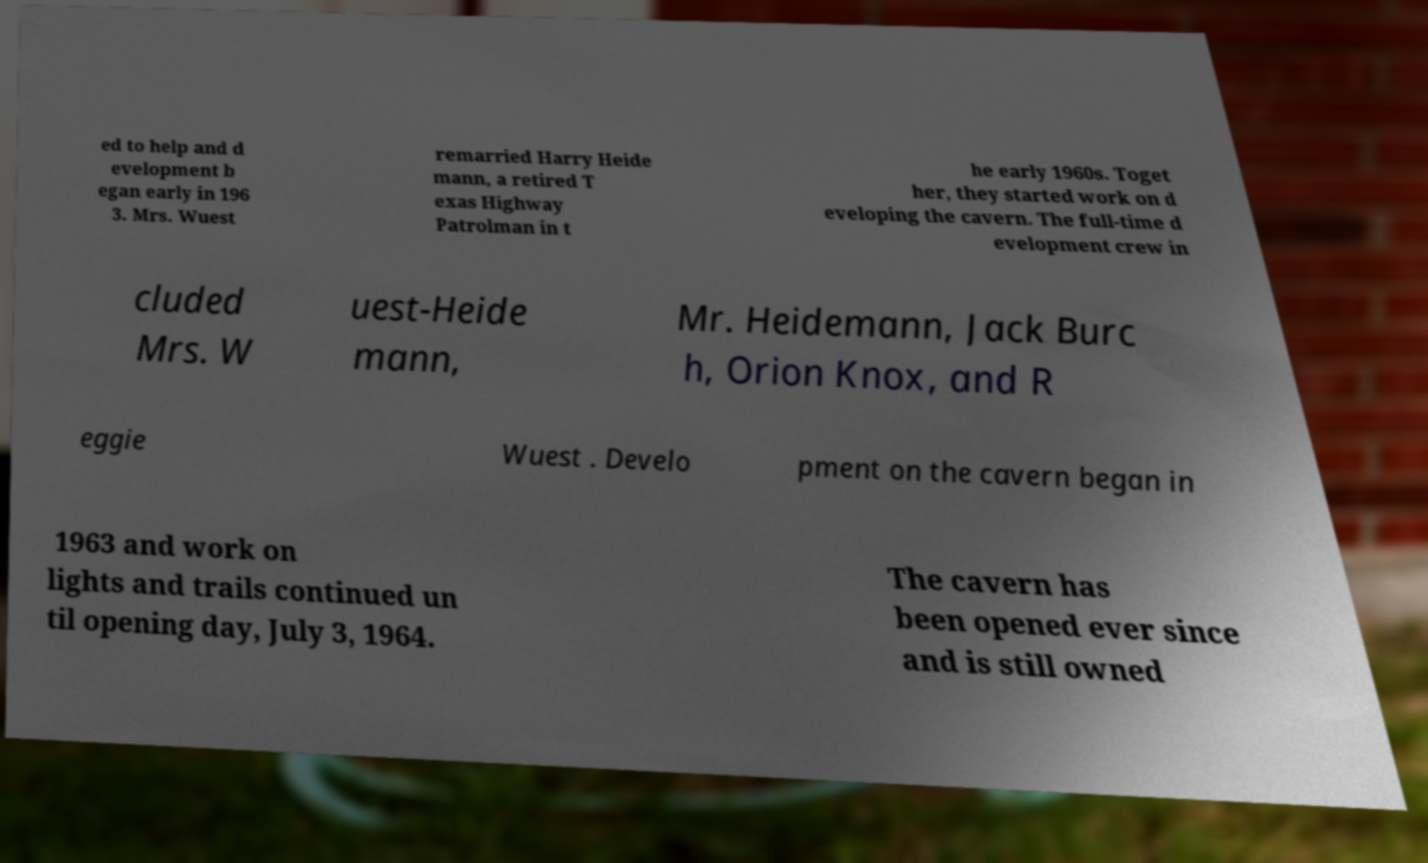What messages or text are displayed in this image? I need them in a readable, typed format. ed to help and d evelopment b egan early in 196 3. Mrs. Wuest remarried Harry Heide mann, a retired T exas Highway Patrolman in t he early 1960s. Toget her, they started work on d eveloping the cavern. The full-time d evelopment crew in cluded Mrs. W uest-Heide mann, Mr. Heidemann, Jack Burc h, Orion Knox, and R eggie Wuest . Develo pment on the cavern began in 1963 and work on lights and trails continued un til opening day, July 3, 1964. The cavern has been opened ever since and is still owned 